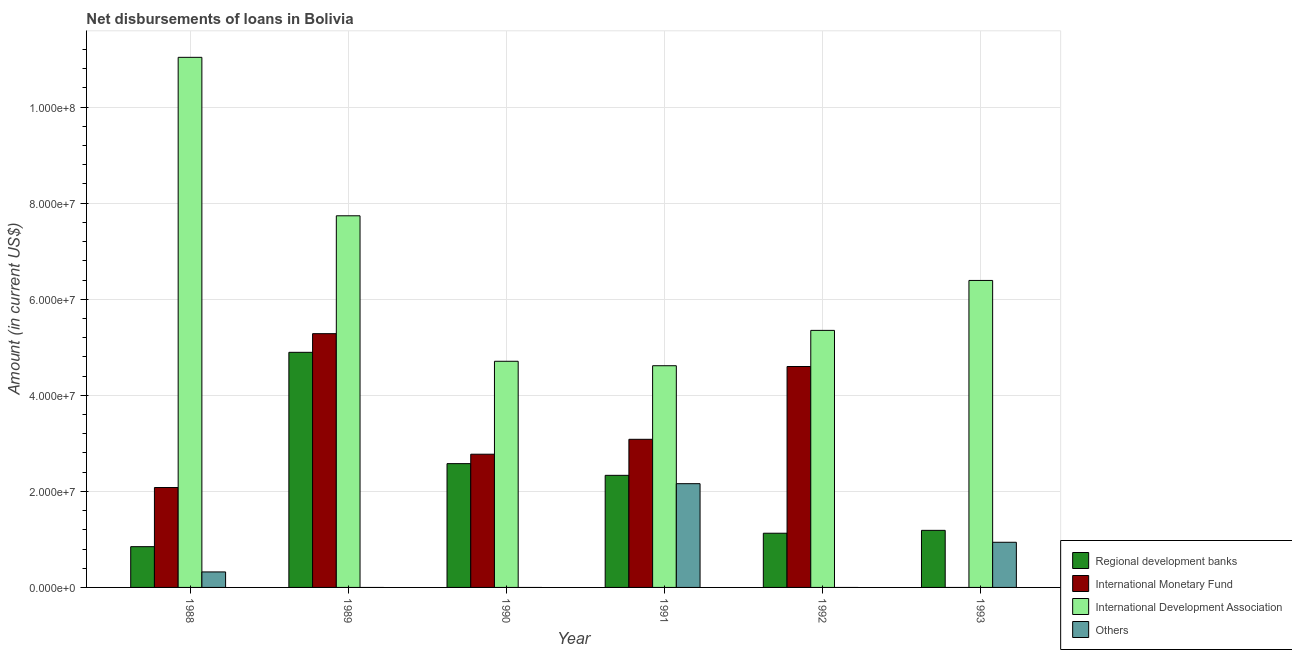In how many cases, is the number of bars for a given year not equal to the number of legend labels?
Your answer should be very brief. 4. What is the amount of loan disimbursed by international development association in 1990?
Ensure brevity in your answer.  4.71e+07. Across all years, what is the maximum amount of loan disimbursed by international development association?
Make the answer very short. 1.10e+08. Across all years, what is the minimum amount of loan disimbursed by international development association?
Ensure brevity in your answer.  4.62e+07. What is the total amount of loan disimbursed by international monetary fund in the graph?
Your answer should be compact. 1.78e+08. What is the difference between the amount of loan disimbursed by international development association in 1990 and that in 1992?
Offer a very short reply. -6.43e+06. What is the difference between the amount of loan disimbursed by regional development banks in 1992 and the amount of loan disimbursed by international development association in 1989?
Keep it short and to the point. -3.77e+07. What is the average amount of loan disimbursed by regional development banks per year?
Your answer should be very brief. 2.16e+07. In how many years, is the amount of loan disimbursed by regional development banks greater than 24000000 US$?
Offer a very short reply. 2. What is the ratio of the amount of loan disimbursed by regional development banks in 1991 to that in 1992?
Keep it short and to the point. 2.07. Is the amount of loan disimbursed by international development association in 1990 less than that in 1991?
Your response must be concise. No. Is the difference between the amount of loan disimbursed by international development association in 1988 and 1992 greater than the difference between the amount of loan disimbursed by regional development banks in 1988 and 1992?
Your answer should be very brief. No. What is the difference between the highest and the second highest amount of loan disimbursed by international monetary fund?
Make the answer very short. 6.84e+06. What is the difference between the highest and the lowest amount of loan disimbursed by international monetary fund?
Give a very brief answer. 5.28e+07. Is the sum of the amount of loan disimbursed by international development association in 1991 and 1992 greater than the maximum amount of loan disimbursed by regional development banks across all years?
Give a very brief answer. No. How many bars are there?
Give a very brief answer. 20. Are all the bars in the graph horizontal?
Provide a succinct answer. No. How many years are there in the graph?
Provide a succinct answer. 6. What is the difference between two consecutive major ticks on the Y-axis?
Offer a very short reply. 2.00e+07. Does the graph contain any zero values?
Give a very brief answer. Yes. Does the graph contain grids?
Provide a short and direct response. Yes. How are the legend labels stacked?
Give a very brief answer. Vertical. What is the title of the graph?
Provide a short and direct response. Net disbursements of loans in Bolivia. Does "Italy" appear as one of the legend labels in the graph?
Offer a very short reply. No. What is the Amount (in current US$) in Regional development banks in 1988?
Keep it short and to the point. 8.49e+06. What is the Amount (in current US$) of International Monetary Fund in 1988?
Provide a short and direct response. 2.08e+07. What is the Amount (in current US$) of International Development Association in 1988?
Your answer should be compact. 1.10e+08. What is the Amount (in current US$) in Others in 1988?
Keep it short and to the point. 3.22e+06. What is the Amount (in current US$) in Regional development banks in 1989?
Offer a very short reply. 4.90e+07. What is the Amount (in current US$) in International Monetary Fund in 1989?
Your answer should be compact. 5.28e+07. What is the Amount (in current US$) of International Development Association in 1989?
Make the answer very short. 7.74e+07. What is the Amount (in current US$) in Regional development banks in 1990?
Your answer should be compact. 2.58e+07. What is the Amount (in current US$) of International Monetary Fund in 1990?
Your response must be concise. 2.77e+07. What is the Amount (in current US$) of International Development Association in 1990?
Your answer should be very brief. 4.71e+07. What is the Amount (in current US$) in Regional development banks in 1991?
Your answer should be compact. 2.33e+07. What is the Amount (in current US$) of International Monetary Fund in 1991?
Your response must be concise. 3.08e+07. What is the Amount (in current US$) in International Development Association in 1991?
Provide a short and direct response. 4.62e+07. What is the Amount (in current US$) of Others in 1991?
Offer a very short reply. 2.16e+07. What is the Amount (in current US$) of Regional development banks in 1992?
Give a very brief answer. 1.13e+07. What is the Amount (in current US$) of International Monetary Fund in 1992?
Provide a succinct answer. 4.60e+07. What is the Amount (in current US$) in International Development Association in 1992?
Ensure brevity in your answer.  5.35e+07. What is the Amount (in current US$) in Others in 1992?
Make the answer very short. 0. What is the Amount (in current US$) in Regional development banks in 1993?
Your answer should be very brief. 1.19e+07. What is the Amount (in current US$) in International Development Association in 1993?
Keep it short and to the point. 6.39e+07. What is the Amount (in current US$) in Others in 1993?
Offer a terse response. 9.40e+06. Across all years, what is the maximum Amount (in current US$) of Regional development banks?
Your answer should be compact. 4.90e+07. Across all years, what is the maximum Amount (in current US$) in International Monetary Fund?
Your response must be concise. 5.28e+07. Across all years, what is the maximum Amount (in current US$) of International Development Association?
Ensure brevity in your answer.  1.10e+08. Across all years, what is the maximum Amount (in current US$) of Others?
Offer a terse response. 2.16e+07. Across all years, what is the minimum Amount (in current US$) in Regional development banks?
Provide a short and direct response. 8.49e+06. Across all years, what is the minimum Amount (in current US$) of International Development Association?
Your answer should be very brief. 4.62e+07. What is the total Amount (in current US$) in Regional development banks in the graph?
Your answer should be compact. 1.30e+08. What is the total Amount (in current US$) of International Monetary Fund in the graph?
Ensure brevity in your answer.  1.78e+08. What is the total Amount (in current US$) in International Development Association in the graph?
Provide a short and direct response. 3.98e+08. What is the total Amount (in current US$) in Others in the graph?
Offer a very short reply. 3.42e+07. What is the difference between the Amount (in current US$) in Regional development banks in 1988 and that in 1989?
Keep it short and to the point. -4.05e+07. What is the difference between the Amount (in current US$) of International Monetary Fund in 1988 and that in 1989?
Give a very brief answer. -3.20e+07. What is the difference between the Amount (in current US$) in International Development Association in 1988 and that in 1989?
Provide a short and direct response. 3.30e+07. What is the difference between the Amount (in current US$) of Regional development banks in 1988 and that in 1990?
Your response must be concise. -1.73e+07. What is the difference between the Amount (in current US$) of International Monetary Fund in 1988 and that in 1990?
Your answer should be very brief. -6.94e+06. What is the difference between the Amount (in current US$) in International Development Association in 1988 and that in 1990?
Your answer should be very brief. 6.33e+07. What is the difference between the Amount (in current US$) of Regional development banks in 1988 and that in 1991?
Your answer should be compact. -1.48e+07. What is the difference between the Amount (in current US$) of International Monetary Fund in 1988 and that in 1991?
Your answer should be very brief. -1.00e+07. What is the difference between the Amount (in current US$) of International Development Association in 1988 and that in 1991?
Keep it short and to the point. 6.42e+07. What is the difference between the Amount (in current US$) in Others in 1988 and that in 1991?
Keep it short and to the point. -1.84e+07. What is the difference between the Amount (in current US$) in Regional development banks in 1988 and that in 1992?
Give a very brief answer. -2.80e+06. What is the difference between the Amount (in current US$) of International Monetary Fund in 1988 and that in 1992?
Offer a terse response. -2.52e+07. What is the difference between the Amount (in current US$) of International Development Association in 1988 and that in 1992?
Make the answer very short. 5.68e+07. What is the difference between the Amount (in current US$) of Regional development banks in 1988 and that in 1993?
Offer a terse response. -3.40e+06. What is the difference between the Amount (in current US$) of International Development Association in 1988 and that in 1993?
Offer a very short reply. 4.65e+07. What is the difference between the Amount (in current US$) in Others in 1988 and that in 1993?
Provide a succinct answer. -6.18e+06. What is the difference between the Amount (in current US$) in Regional development banks in 1989 and that in 1990?
Give a very brief answer. 2.32e+07. What is the difference between the Amount (in current US$) of International Monetary Fund in 1989 and that in 1990?
Offer a terse response. 2.51e+07. What is the difference between the Amount (in current US$) in International Development Association in 1989 and that in 1990?
Give a very brief answer. 3.03e+07. What is the difference between the Amount (in current US$) in Regional development banks in 1989 and that in 1991?
Provide a short and direct response. 2.56e+07. What is the difference between the Amount (in current US$) of International Monetary Fund in 1989 and that in 1991?
Offer a terse response. 2.20e+07. What is the difference between the Amount (in current US$) of International Development Association in 1989 and that in 1991?
Your answer should be compact. 3.12e+07. What is the difference between the Amount (in current US$) of Regional development banks in 1989 and that in 1992?
Provide a short and direct response. 3.77e+07. What is the difference between the Amount (in current US$) in International Monetary Fund in 1989 and that in 1992?
Ensure brevity in your answer.  6.84e+06. What is the difference between the Amount (in current US$) in International Development Association in 1989 and that in 1992?
Provide a succinct answer. 2.39e+07. What is the difference between the Amount (in current US$) in Regional development banks in 1989 and that in 1993?
Give a very brief answer. 3.71e+07. What is the difference between the Amount (in current US$) of International Development Association in 1989 and that in 1993?
Your response must be concise. 1.35e+07. What is the difference between the Amount (in current US$) in Regional development banks in 1990 and that in 1991?
Make the answer very short. 2.44e+06. What is the difference between the Amount (in current US$) in International Monetary Fund in 1990 and that in 1991?
Ensure brevity in your answer.  -3.10e+06. What is the difference between the Amount (in current US$) of International Development Association in 1990 and that in 1991?
Keep it short and to the point. 9.27e+05. What is the difference between the Amount (in current US$) of Regional development banks in 1990 and that in 1992?
Your response must be concise. 1.45e+07. What is the difference between the Amount (in current US$) of International Monetary Fund in 1990 and that in 1992?
Provide a short and direct response. -1.83e+07. What is the difference between the Amount (in current US$) of International Development Association in 1990 and that in 1992?
Keep it short and to the point. -6.43e+06. What is the difference between the Amount (in current US$) of Regional development banks in 1990 and that in 1993?
Your response must be concise. 1.39e+07. What is the difference between the Amount (in current US$) in International Development Association in 1990 and that in 1993?
Provide a succinct answer. -1.68e+07. What is the difference between the Amount (in current US$) in Regional development banks in 1991 and that in 1992?
Give a very brief answer. 1.21e+07. What is the difference between the Amount (in current US$) in International Monetary Fund in 1991 and that in 1992?
Provide a succinct answer. -1.52e+07. What is the difference between the Amount (in current US$) in International Development Association in 1991 and that in 1992?
Provide a succinct answer. -7.36e+06. What is the difference between the Amount (in current US$) of Regional development banks in 1991 and that in 1993?
Your response must be concise. 1.15e+07. What is the difference between the Amount (in current US$) in International Development Association in 1991 and that in 1993?
Provide a succinct answer. -1.78e+07. What is the difference between the Amount (in current US$) in Others in 1991 and that in 1993?
Ensure brevity in your answer.  1.22e+07. What is the difference between the Amount (in current US$) of Regional development banks in 1992 and that in 1993?
Your response must be concise. -5.99e+05. What is the difference between the Amount (in current US$) of International Development Association in 1992 and that in 1993?
Ensure brevity in your answer.  -1.04e+07. What is the difference between the Amount (in current US$) of Regional development banks in 1988 and the Amount (in current US$) of International Monetary Fund in 1989?
Keep it short and to the point. -4.43e+07. What is the difference between the Amount (in current US$) in Regional development banks in 1988 and the Amount (in current US$) in International Development Association in 1989?
Give a very brief answer. -6.89e+07. What is the difference between the Amount (in current US$) in International Monetary Fund in 1988 and the Amount (in current US$) in International Development Association in 1989?
Offer a very short reply. -5.66e+07. What is the difference between the Amount (in current US$) in Regional development banks in 1988 and the Amount (in current US$) in International Monetary Fund in 1990?
Provide a short and direct response. -1.92e+07. What is the difference between the Amount (in current US$) in Regional development banks in 1988 and the Amount (in current US$) in International Development Association in 1990?
Provide a short and direct response. -3.86e+07. What is the difference between the Amount (in current US$) of International Monetary Fund in 1988 and the Amount (in current US$) of International Development Association in 1990?
Make the answer very short. -2.63e+07. What is the difference between the Amount (in current US$) in Regional development banks in 1988 and the Amount (in current US$) in International Monetary Fund in 1991?
Offer a terse response. -2.24e+07. What is the difference between the Amount (in current US$) of Regional development banks in 1988 and the Amount (in current US$) of International Development Association in 1991?
Offer a terse response. -3.77e+07. What is the difference between the Amount (in current US$) in Regional development banks in 1988 and the Amount (in current US$) in Others in 1991?
Your response must be concise. -1.31e+07. What is the difference between the Amount (in current US$) of International Monetary Fund in 1988 and the Amount (in current US$) of International Development Association in 1991?
Give a very brief answer. -2.54e+07. What is the difference between the Amount (in current US$) of International Monetary Fund in 1988 and the Amount (in current US$) of Others in 1991?
Provide a succinct answer. -8.02e+05. What is the difference between the Amount (in current US$) in International Development Association in 1988 and the Amount (in current US$) in Others in 1991?
Your answer should be very brief. 8.88e+07. What is the difference between the Amount (in current US$) of Regional development banks in 1988 and the Amount (in current US$) of International Monetary Fund in 1992?
Provide a succinct answer. -3.75e+07. What is the difference between the Amount (in current US$) of Regional development banks in 1988 and the Amount (in current US$) of International Development Association in 1992?
Make the answer very short. -4.50e+07. What is the difference between the Amount (in current US$) of International Monetary Fund in 1988 and the Amount (in current US$) of International Development Association in 1992?
Ensure brevity in your answer.  -3.27e+07. What is the difference between the Amount (in current US$) in Regional development banks in 1988 and the Amount (in current US$) in International Development Association in 1993?
Make the answer very short. -5.54e+07. What is the difference between the Amount (in current US$) of Regional development banks in 1988 and the Amount (in current US$) of Others in 1993?
Your answer should be compact. -9.16e+05. What is the difference between the Amount (in current US$) of International Monetary Fund in 1988 and the Amount (in current US$) of International Development Association in 1993?
Give a very brief answer. -4.31e+07. What is the difference between the Amount (in current US$) in International Monetary Fund in 1988 and the Amount (in current US$) in Others in 1993?
Your response must be concise. 1.14e+07. What is the difference between the Amount (in current US$) of International Development Association in 1988 and the Amount (in current US$) of Others in 1993?
Offer a very short reply. 1.01e+08. What is the difference between the Amount (in current US$) in Regional development banks in 1989 and the Amount (in current US$) in International Monetary Fund in 1990?
Offer a terse response. 2.12e+07. What is the difference between the Amount (in current US$) in Regional development banks in 1989 and the Amount (in current US$) in International Development Association in 1990?
Provide a succinct answer. 1.87e+06. What is the difference between the Amount (in current US$) of International Monetary Fund in 1989 and the Amount (in current US$) of International Development Association in 1990?
Your response must be concise. 5.75e+06. What is the difference between the Amount (in current US$) of Regional development banks in 1989 and the Amount (in current US$) of International Monetary Fund in 1991?
Make the answer very short. 1.81e+07. What is the difference between the Amount (in current US$) of Regional development banks in 1989 and the Amount (in current US$) of International Development Association in 1991?
Provide a succinct answer. 2.79e+06. What is the difference between the Amount (in current US$) of Regional development banks in 1989 and the Amount (in current US$) of Others in 1991?
Provide a short and direct response. 2.73e+07. What is the difference between the Amount (in current US$) of International Monetary Fund in 1989 and the Amount (in current US$) of International Development Association in 1991?
Ensure brevity in your answer.  6.68e+06. What is the difference between the Amount (in current US$) in International Monetary Fund in 1989 and the Amount (in current US$) in Others in 1991?
Give a very brief answer. 3.12e+07. What is the difference between the Amount (in current US$) of International Development Association in 1989 and the Amount (in current US$) of Others in 1991?
Give a very brief answer. 5.58e+07. What is the difference between the Amount (in current US$) of Regional development banks in 1989 and the Amount (in current US$) of International Monetary Fund in 1992?
Keep it short and to the point. 2.96e+06. What is the difference between the Amount (in current US$) in Regional development banks in 1989 and the Amount (in current US$) in International Development Association in 1992?
Your answer should be very brief. -4.57e+06. What is the difference between the Amount (in current US$) in International Monetary Fund in 1989 and the Amount (in current US$) in International Development Association in 1992?
Your answer should be compact. -6.84e+05. What is the difference between the Amount (in current US$) of Regional development banks in 1989 and the Amount (in current US$) of International Development Association in 1993?
Make the answer very short. -1.50e+07. What is the difference between the Amount (in current US$) in Regional development banks in 1989 and the Amount (in current US$) in Others in 1993?
Offer a terse response. 3.95e+07. What is the difference between the Amount (in current US$) in International Monetary Fund in 1989 and the Amount (in current US$) in International Development Association in 1993?
Your answer should be very brief. -1.11e+07. What is the difference between the Amount (in current US$) of International Monetary Fund in 1989 and the Amount (in current US$) of Others in 1993?
Your response must be concise. 4.34e+07. What is the difference between the Amount (in current US$) in International Development Association in 1989 and the Amount (in current US$) in Others in 1993?
Your answer should be very brief. 6.80e+07. What is the difference between the Amount (in current US$) in Regional development banks in 1990 and the Amount (in current US$) in International Monetary Fund in 1991?
Offer a terse response. -5.07e+06. What is the difference between the Amount (in current US$) of Regional development banks in 1990 and the Amount (in current US$) of International Development Association in 1991?
Your response must be concise. -2.04e+07. What is the difference between the Amount (in current US$) in Regional development banks in 1990 and the Amount (in current US$) in Others in 1991?
Offer a terse response. 4.17e+06. What is the difference between the Amount (in current US$) in International Monetary Fund in 1990 and the Amount (in current US$) in International Development Association in 1991?
Provide a succinct answer. -1.84e+07. What is the difference between the Amount (in current US$) of International Monetary Fund in 1990 and the Amount (in current US$) of Others in 1991?
Make the answer very short. 6.14e+06. What is the difference between the Amount (in current US$) of International Development Association in 1990 and the Amount (in current US$) of Others in 1991?
Your response must be concise. 2.55e+07. What is the difference between the Amount (in current US$) in Regional development banks in 1990 and the Amount (in current US$) in International Monetary Fund in 1992?
Your response must be concise. -2.02e+07. What is the difference between the Amount (in current US$) in Regional development banks in 1990 and the Amount (in current US$) in International Development Association in 1992?
Offer a very short reply. -2.77e+07. What is the difference between the Amount (in current US$) of International Monetary Fund in 1990 and the Amount (in current US$) of International Development Association in 1992?
Make the answer very short. -2.58e+07. What is the difference between the Amount (in current US$) in Regional development banks in 1990 and the Amount (in current US$) in International Development Association in 1993?
Offer a very short reply. -3.81e+07. What is the difference between the Amount (in current US$) in Regional development banks in 1990 and the Amount (in current US$) in Others in 1993?
Your answer should be very brief. 1.64e+07. What is the difference between the Amount (in current US$) in International Monetary Fund in 1990 and the Amount (in current US$) in International Development Association in 1993?
Offer a terse response. -3.62e+07. What is the difference between the Amount (in current US$) in International Monetary Fund in 1990 and the Amount (in current US$) in Others in 1993?
Your response must be concise. 1.83e+07. What is the difference between the Amount (in current US$) in International Development Association in 1990 and the Amount (in current US$) in Others in 1993?
Offer a terse response. 3.77e+07. What is the difference between the Amount (in current US$) of Regional development banks in 1991 and the Amount (in current US$) of International Monetary Fund in 1992?
Provide a short and direct response. -2.27e+07. What is the difference between the Amount (in current US$) of Regional development banks in 1991 and the Amount (in current US$) of International Development Association in 1992?
Offer a terse response. -3.02e+07. What is the difference between the Amount (in current US$) in International Monetary Fund in 1991 and the Amount (in current US$) in International Development Association in 1992?
Keep it short and to the point. -2.27e+07. What is the difference between the Amount (in current US$) in Regional development banks in 1991 and the Amount (in current US$) in International Development Association in 1993?
Ensure brevity in your answer.  -4.06e+07. What is the difference between the Amount (in current US$) in Regional development banks in 1991 and the Amount (in current US$) in Others in 1993?
Make the answer very short. 1.39e+07. What is the difference between the Amount (in current US$) of International Monetary Fund in 1991 and the Amount (in current US$) of International Development Association in 1993?
Your answer should be very brief. -3.31e+07. What is the difference between the Amount (in current US$) of International Monetary Fund in 1991 and the Amount (in current US$) of Others in 1993?
Ensure brevity in your answer.  2.14e+07. What is the difference between the Amount (in current US$) of International Development Association in 1991 and the Amount (in current US$) of Others in 1993?
Provide a short and direct response. 3.68e+07. What is the difference between the Amount (in current US$) in Regional development banks in 1992 and the Amount (in current US$) in International Development Association in 1993?
Your answer should be very brief. -5.26e+07. What is the difference between the Amount (in current US$) in Regional development banks in 1992 and the Amount (in current US$) in Others in 1993?
Offer a terse response. 1.88e+06. What is the difference between the Amount (in current US$) in International Monetary Fund in 1992 and the Amount (in current US$) in International Development Association in 1993?
Keep it short and to the point. -1.79e+07. What is the difference between the Amount (in current US$) of International Monetary Fund in 1992 and the Amount (in current US$) of Others in 1993?
Provide a succinct answer. 3.66e+07. What is the difference between the Amount (in current US$) in International Development Association in 1992 and the Amount (in current US$) in Others in 1993?
Provide a succinct answer. 4.41e+07. What is the average Amount (in current US$) in Regional development banks per year?
Provide a succinct answer. 2.16e+07. What is the average Amount (in current US$) of International Monetary Fund per year?
Ensure brevity in your answer.  2.97e+07. What is the average Amount (in current US$) in International Development Association per year?
Offer a very short reply. 6.64e+07. What is the average Amount (in current US$) in Others per year?
Your response must be concise. 5.70e+06. In the year 1988, what is the difference between the Amount (in current US$) in Regional development banks and Amount (in current US$) in International Monetary Fund?
Keep it short and to the point. -1.23e+07. In the year 1988, what is the difference between the Amount (in current US$) in Regional development banks and Amount (in current US$) in International Development Association?
Ensure brevity in your answer.  -1.02e+08. In the year 1988, what is the difference between the Amount (in current US$) of Regional development banks and Amount (in current US$) of Others?
Keep it short and to the point. 5.26e+06. In the year 1988, what is the difference between the Amount (in current US$) in International Monetary Fund and Amount (in current US$) in International Development Association?
Your answer should be very brief. -8.96e+07. In the year 1988, what is the difference between the Amount (in current US$) in International Monetary Fund and Amount (in current US$) in Others?
Offer a very short reply. 1.76e+07. In the year 1988, what is the difference between the Amount (in current US$) of International Development Association and Amount (in current US$) of Others?
Your answer should be very brief. 1.07e+08. In the year 1989, what is the difference between the Amount (in current US$) in Regional development banks and Amount (in current US$) in International Monetary Fund?
Your answer should be compact. -3.88e+06. In the year 1989, what is the difference between the Amount (in current US$) in Regional development banks and Amount (in current US$) in International Development Association?
Offer a terse response. -2.84e+07. In the year 1989, what is the difference between the Amount (in current US$) of International Monetary Fund and Amount (in current US$) of International Development Association?
Provide a short and direct response. -2.45e+07. In the year 1990, what is the difference between the Amount (in current US$) of Regional development banks and Amount (in current US$) of International Monetary Fund?
Make the answer very short. -1.96e+06. In the year 1990, what is the difference between the Amount (in current US$) in Regional development banks and Amount (in current US$) in International Development Association?
Your answer should be compact. -2.13e+07. In the year 1990, what is the difference between the Amount (in current US$) of International Monetary Fund and Amount (in current US$) of International Development Association?
Make the answer very short. -1.93e+07. In the year 1991, what is the difference between the Amount (in current US$) in Regional development banks and Amount (in current US$) in International Monetary Fund?
Keep it short and to the point. -7.50e+06. In the year 1991, what is the difference between the Amount (in current US$) of Regional development banks and Amount (in current US$) of International Development Association?
Provide a short and direct response. -2.28e+07. In the year 1991, what is the difference between the Amount (in current US$) of Regional development banks and Amount (in current US$) of Others?
Provide a short and direct response. 1.74e+06. In the year 1991, what is the difference between the Amount (in current US$) of International Monetary Fund and Amount (in current US$) of International Development Association?
Offer a very short reply. -1.53e+07. In the year 1991, what is the difference between the Amount (in current US$) of International Monetary Fund and Amount (in current US$) of Others?
Make the answer very short. 9.24e+06. In the year 1991, what is the difference between the Amount (in current US$) of International Development Association and Amount (in current US$) of Others?
Offer a very short reply. 2.46e+07. In the year 1992, what is the difference between the Amount (in current US$) of Regional development banks and Amount (in current US$) of International Monetary Fund?
Make the answer very short. -3.47e+07. In the year 1992, what is the difference between the Amount (in current US$) in Regional development banks and Amount (in current US$) in International Development Association?
Give a very brief answer. -4.22e+07. In the year 1992, what is the difference between the Amount (in current US$) of International Monetary Fund and Amount (in current US$) of International Development Association?
Provide a short and direct response. -7.52e+06. In the year 1993, what is the difference between the Amount (in current US$) of Regional development banks and Amount (in current US$) of International Development Association?
Offer a very short reply. -5.20e+07. In the year 1993, what is the difference between the Amount (in current US$) in Regional development banks and Amount (in current US$) in Others?
Your answer should be very brief. 2.48e+06. In the year 1993, what is the difference between the Amount (in current US$) of International Development Association and Amount (in current US$) of Others?
Your answer should be very brief. 5.45e+07. What is the ratio of the Amount (in current US$) of Regional development banks in 1988 to that in 1989?
Provide a short and direct response. 0.17. What is the ratio of the Amount (in current US$) of International Monetary Fund in 1988 to that in 1989?
Offer a very short reply. 0.39. What is the ratio of the Amount (in current US$) in International Development Association in 1988 to that in 1989?
Offer a terse response. 1.43. What is the ratio of the Amount (in current US$) of Regional development banks in 1988 to that in 1990?
Keep it short and to the point. 0.33. What is the ratio of the Amount (in current US$) of International Monetary Fund in 1988 to that in 1990?
Provide a succinct answer. 0.75. What is the ratio of the Amount (in current US$) in International Development Association in 1988 to that in 1990?
Provide a short and direct response. 2.34. What is the ratio of the Amount (in current US$) in Regional development banks in 1988 to that in 1991?
Your response must be concise. 0.36. What is the ratio of the Amount (in current US$) in International Monetary Fund in 1988 to that in 1991?
Ensure brevity in your answer.  0.67. What is the ratio of the Amount (in current US$) in International Development Association in 1988 to that in 1991?
Offer a very short reply. 2.39. What is the ratio of the Amount (in current US$) in Others in 1988 to that in 1991?
Give a very brief answer. 0.15. What is the ratio of the Amount (in current US$) in Regional development banks in 1988 to that in 1992?
Offer a very short reply. 0.75. What is the ratio of the Amount (in current US$) in International Monetary Fund in 1988 to that in 1992?
Offer a very short reply. 0.45. What is the ratio of the Amount (in current US$) of International Development Association in 1988 to that in 1992?
Your answer should be compact. 2.06. What is the ratio of the Amount (in current US$) of Regional development banks in 1988 to that in 1993?
Keep it short and to the point. 0.71. What is the ratio of the Amount (in current US$) of International Development Association in 1988 to that in 1993?
Offer a very short reply. 1.73. What is the ratio of the Amount (in current US$) of Others in 1988 to that in 1993?
Make the answer very short. 0.34. What is the ratio of the Amount (in current US$) of Regional development banks in 1989 to that in 1990?
Provide a short and direct response. 1.9. What is the ratio of the Amount (in current US$) of International Monetary Fund in 1989 to that in 1990?
Your answer should be very brief. 1.9. What is the ratio of the Amount (in current US$) of International Development Association in 1989 to that in 1990?
Ensure brevity in your answer.  1.64. What is the ratio of the Amount (in current US$) in Regional development banks in 1989 to that in 1991?
Your answer should be compact. 2.1. What is the ratio of the Amount (in current US$) in International Monetary Fund in 1989 to that in 1991?
Your answer should be very brief. 1.71. What is the ratio of the Amount (in current US$) in International Development Association in 1989 to that in 1991?
Ensure brevity in your answer.  1.68. What is the ratio of the Amount (in current US$) in Regional development banks in 1989 to that in 1992?
Ensure brevity in your answer.  4.34. What is the ratio of the Amount (in current US$) in International Monetary Fund in 1989 to that in 1992?
Ensure brevity in your answer.  1.15. What is the ratio of the Amount (in current US$) of International Development Association in 1989 to that in 1992?
Keep it short and to the point. 1.45. What is the ratio of the Amount (in current US$) in Regional development banks in 1989 to that in 1993?
Give a very brief answer. 4.12. What is the ratio of the Amount (in current US$) in International Development Association in 1989 to that in 1993?
Offer a terse response. 1.21. What is the ratio of the Amount (in current US$) in Regional development banks in 1990 to that in 1991?
Your answer should be compact. 1.1. What is the ratio of the Amount (in current US$) in International Monetary Fund in 1990 to that in 1991?
Ensure brevity in your answer.  0.9. What is the ratio of the Amount (in current US$) of International Development Association in 1990 to that in 1991?
Keep it short and to the point. 1.02. What is the ratio of the Amount (in current US$) in Regional development banks in 1990 to that in 1992?
Provide a short and direct response. 2.28. What is the ratio of the Amount (in current US$) of International Monetary Fund in 1990 to that in 1992?
Keep it short and to the point. 0.6. What is the ratio of the Amount (in current US$) of International Development Association in 1990 to that in 1992?
Make the answer very short. 0.88. What is the ratio of the Amount (in current US$) in Regional development banks in 1990 to that in 1993?
Your answer should be compact. 2.17. What is the ratio of the Amount (in current US$) of International Development Association in 1990 to that in 1993?
Your answer should be very brief. 0.74. What is the ratio of the Amount (in current US$) of Regional development banks in 1991 to that in 1992?
Offer a very short reply. 2.07. What is the ratio of the Amount (in current US$) in International Monetary Fund in 1991 to that in 1992?
Keep it short and to the point. 0.67. What is the ratio of the Amount (in current US$) of International Development Association in 1991 to that in 1992?
Offer a very short reply. 0.86. What is the ratio of the Amount (in current US$) of Regional development banks in 1991 to that in 1993?
Keep it short and to the point. 1.96. What is the ratio of the Amount (in current US$) in International Development Association in 1991 to that in 1993?
Make the answer very short. 0.72. What is the ratio of the Amount (in current US$) in Others in 1991 to that in 1993?
Provide a succinct answer. 2.3. What is the ratio of the Amount (in current US$) of Regional development banks in 1992 to that in 1993?
Offer a very short reply. 0.95. What is the ratio of the Amount (in current US$) of International Development Association in 1992 to that in 1993?
Your answer should be compact. 0.84. What is the difference between the highest and the second highest Amount (in current US$) in Regional development banks?
Give a very brief answer. 2.32e+07. What is the difference between the highest and the second highest Amount (in current US$) in International Monetary Fund?
Your answer should be very brief. 6.84e+06. What is the difference between the highest and the second highest Amount (in current US$) of International Development Association?
Ensure brevity in your answer.  3.30e+07. What is the difference between the highest and the second highest Amount (in current US$) in Others?
Provide a succinct answer. 1.22e+07. What is the difference between the highest and the lowest Amount (in current US$) in Regional development banks?
Provide a succinct answer. 4.05e+07. What is the difference between the highest and the lowest Amount (in current US$) of International Monetary Fund?
Provide a succinct answer. 5.28e+07. What is the difference between the highest and the lowest Amount (in current US$) of International Development Association?
Provide a short and direct response. 6.42e+07. What is the difference between the highest and the lowest Amount (in current US$) in Others?
Offer a terse response. 2.16e+07. 